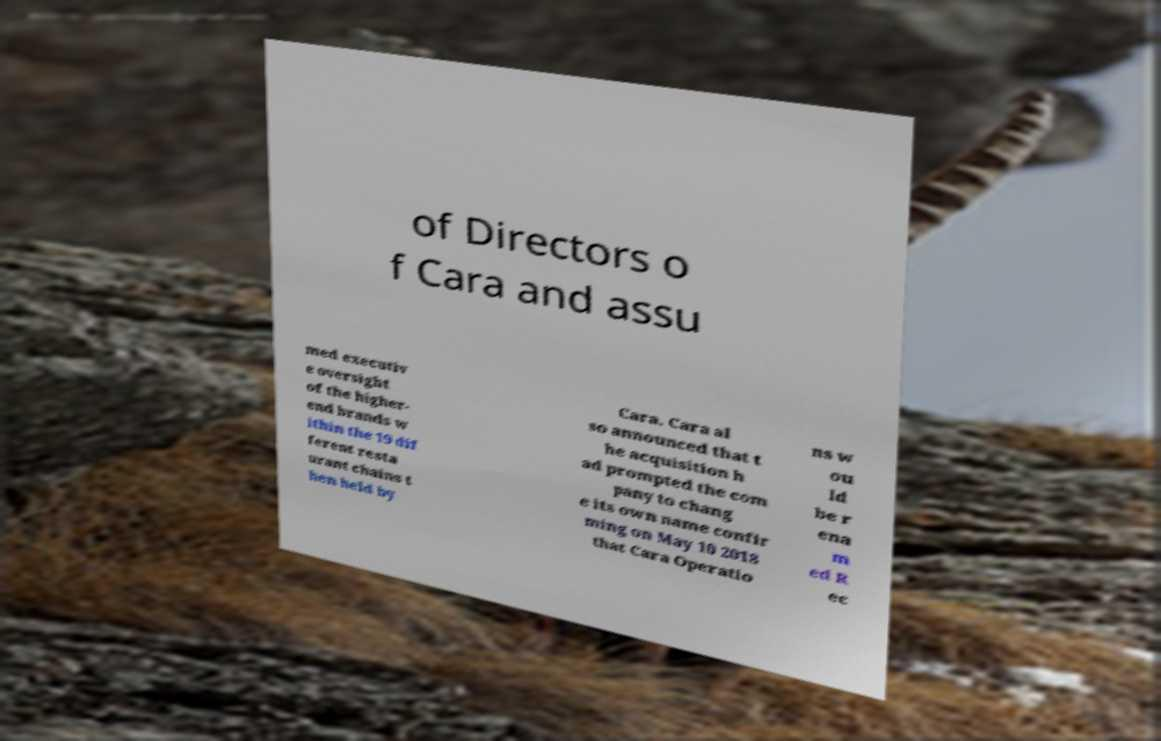What messages or text are displayed in this image? I need them in a readable, typed format. of Directors o f Cara and assu med executiv e oversight of the higher- end brands w ithin the 19 dif ferent resta urant chains t hen held by Cara. Cara al so announced that t he acquisition h ad prompted the com pany to chang e its own name confir ming on May 10 2018 that Cara Operatio ns w ou ld be r ena m ed R ec 